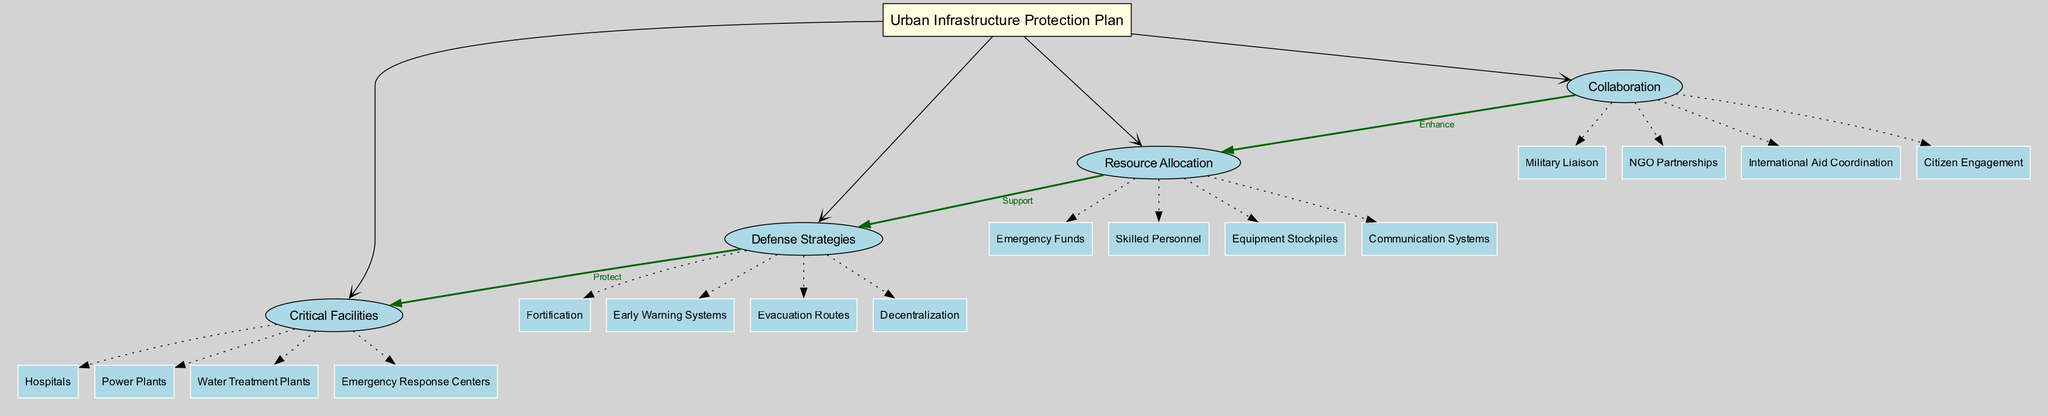What is the central node of the diagram? The central node is specified as "Urban Infrastructure Protection Plan." This is the main concept that connects all other branches and sub-branches in the diagram.
Answer: Urban Infrastructure Protection Plan How many main branches are there? The diagram lists 4 main branches: "Critical Facilities," "Defense Strategies," "Resource Allocation," and "Collaboration." Therefore, by counting these branches, the total becomes 4.
Answer: 4 What are the sub-branches of the "Resource Allocation" main branch? The diagram notes that the sub-branches of "Resource Allocation" include "Emergency Funds," "Skilled Personnel," "Equipment Stockpiles," and "Communication Systems." Therefore, these four entities make up the sub-branches.
Answer: Emergency Funds, Skilled Personnel, Equipment Stockpiles, Communication Systems Which main branch is linked to "Critical Facilities" with the label "Protect"? In the connections detailed in the diagram, the "Defense Strategies" main branch is connected to "Critical Facilities" with the label "Protect." This means that the defense strategies aim to safeguard the critical facilities.
Answer: Defense Strategies How does "Collaboration" enhance "Resource Allocation"? The connection labeled "Enhance" indicates that "Collaboration" improves or increases the effectiveness of "Resource Allocation." This implies that working together with various entities leads to better allocation of resources necessary for infrastructure protection.
Answer: Enhance What connections are shown from "Resource Allocation"? The diagram illustrates two connections originating from "Resource Allocation": one to "Defense Strategies" (labeled "Support") and another to "Collaboration" (labeled "Enhance"). Thus, these two relationships can be observed.
Answer: Support, Enhance Which critical facility has the highest number of sub-branches associated in this diagram? There is an equal number of sub-branches under "Critical Facilities," with each category representing essential services that may require protection. This indicates that all of these critical facilities share an equal level of focus, with 4 sub-branches each.
Answer: 4 What defense strategy involves evacuation? Within the "Defense Strategies" main branch, the sub-branch specifically related to evacuation is labeled "Evacuation Routes." This indicates that planning for evacuation is part of the defense strategy.
Answer: Evacuation Routes Which main branch provides the skilled personnel needed? "Resource Allocation" is the main branch responsible for providing the "Skilled Personnel." This implies that the resources available for protection include trained individuals.
Answer: Resource Allocation 